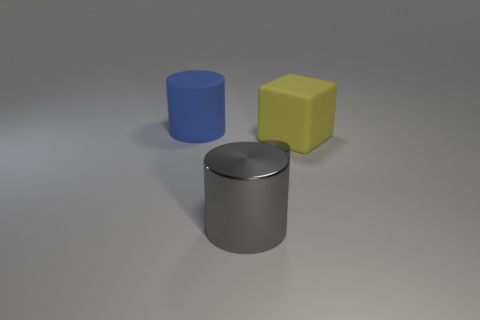Does the rubber thing that is behind the big cube have the same size as the gray metallic cylinder in front of the small thing?
Your answer should be compact. Yes. How many other objects are the same size as the yellow block?
Your response must be concise. 2. There is a yellow block that is in front of the big blue rubber thing; how many large blue things are in front of it?
Your response must be concise. 0. Are there fewer rubber cylinders right of the big gray shiny cylinder than brown objects?
Provide a short and direct response. No. What is the shape of the rubber object that is on the right side of the rubber object left of the tiny shiny cylinder in front of the large blue object?
Provide a succinct answer. Cube. Do the blue thing and the tiny metallic thing have the same shape?
Ensure brevity in your answer.  Yes. How many other things are there of the same shape as the yellow thing?
Offer a terse response. 0. The metallic object that is the same size as the yellow matte object is what color?
Your answer should be very brief. Gray. Are there the same number of big blue cylinders to the right of the blue cylinder and gray metallic things?
Offer a terse response. No. What shape is the thing that is both in front of the yellow cube and to the left of the tiny gray metal cylinder?
Provide a short and direct response. Cylinder. 